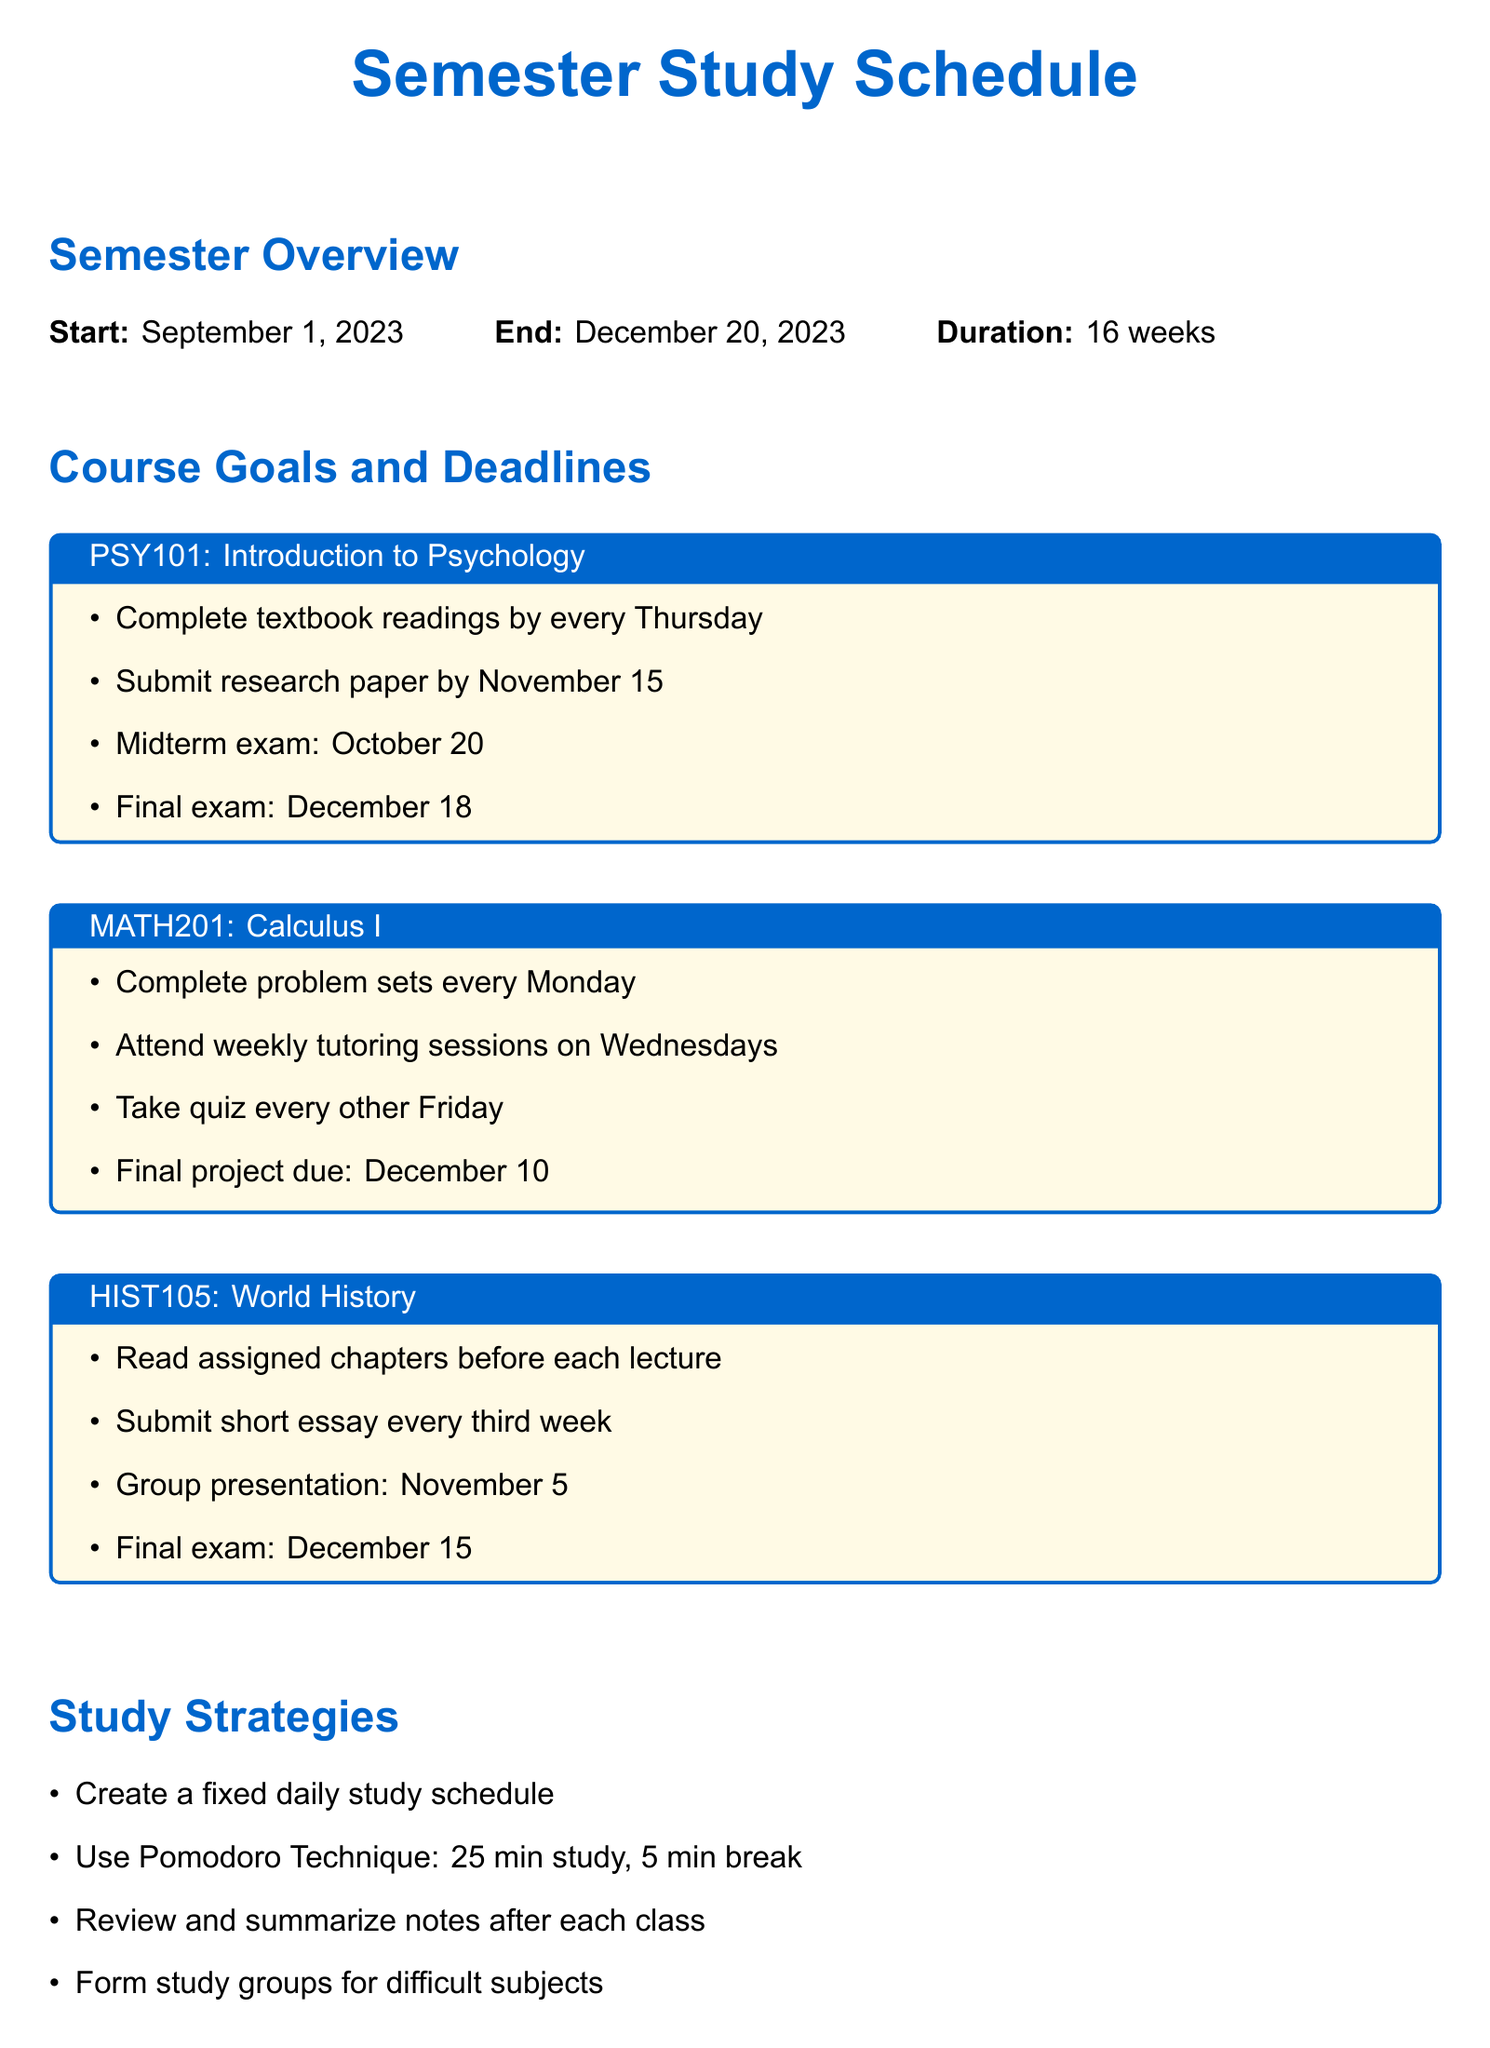What is the start date of the semester? The start date of the semester is mentioned in the semester overview section.
Answer: September 1, 2023 What is the final exam date for World History? The final exam date for World History is listed under the course goals and deadlines.
Answer: December 15 How many courses are included in the study schedule? The number of courses can be counted from the courses section in the document.
Answer: 3 What is the due date for the research paper in Introduction to Psychology? The due date for the research paper is specified in the course goals for Introduction to Psychology.
Answer: November 15 What study technique involves 25 minutes of study followed by a break? This technique is mentioned in the study strategies section of the document.
Answer: Pomodoro Technique When is the group presentation for World History scheduled? The date for the group presentation is provided in the course goals for World History.
Answer: November 5 What is one resource listed for academic assistance? The resources section lists several options for academic assistance.
Answer: University library How often should problem sets be completed for Calculus I? This frequency is detailed in the course goals for Calculus I.
Answer: Every Monday What is a time management tip mentioned in the document? The document contains several tips on managing time effectively.
Answer: Use a physical planner to track deadlines 